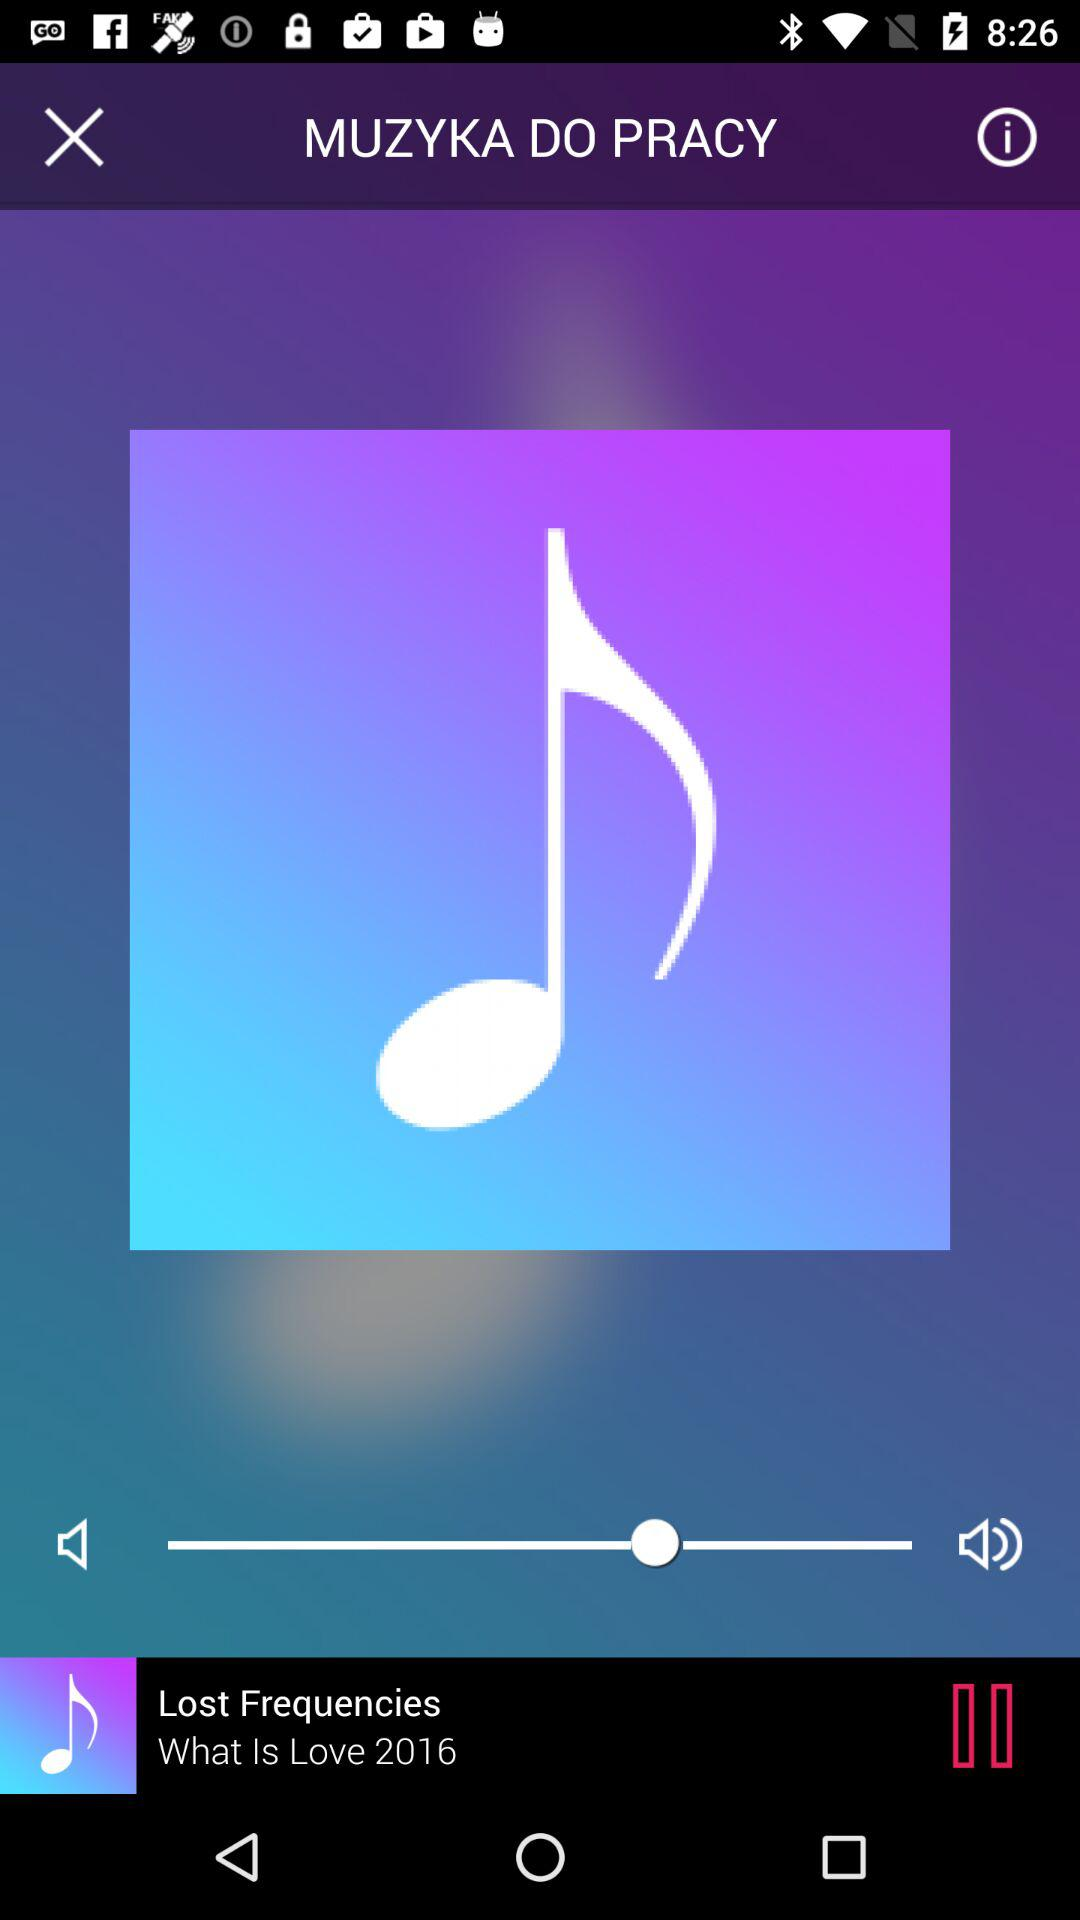Which audio is playing? The audio "What Is Love 2016" is playing. 